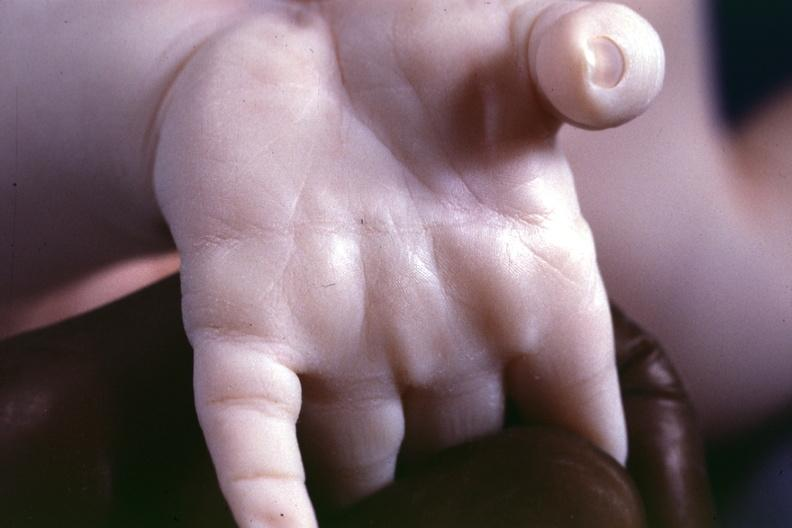s atrophy present?
Answer the question using a single word or phrase. No 